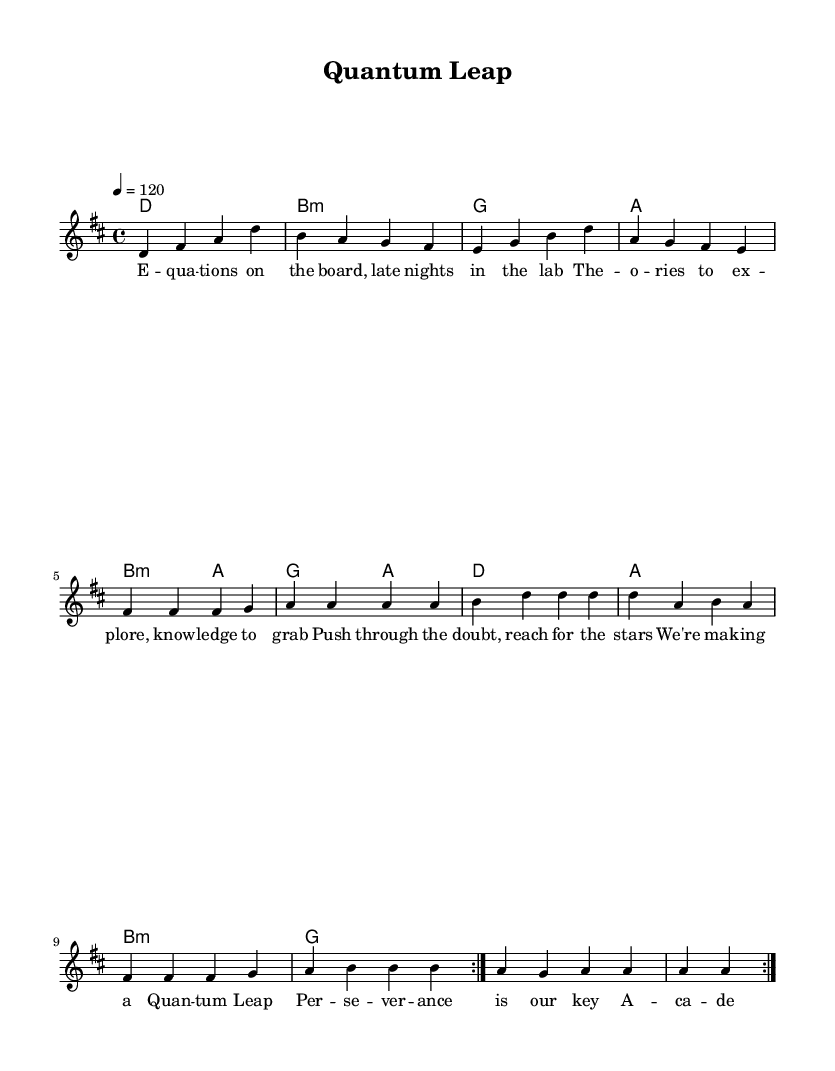What is the key signature of this music? The key signature is D major, which features two sharps (F# and C#). This can be identified at the beginning of the score where the key signature is placed.
Answer: D major What is the time signature of this music? The time signature is 4/4, indicating four beats in each measure and that a quarter note gets one beat. This is directly shown in the score next to the key signature.
Answer: 4/4 What is the tempo marking of this music? The tempo marking is 120 beats per minute, indicated by the instruction "4 = 120" at the beginning of the score, which specifies the speed at which the piece should be played.
Answer: 120 How many measures are in the repeated section? The repeated section consists of 8 measures as indicated by the repeat sign at the end of the first section. Counting the notes in this section confirms 8 measures are present.
Answer: 8 What are the first two words of the lyrics? The first two words of the lyrics are "E" and "qua", which can be found at the beginning of the lyric text under the melody.
Answer: E qua Which chord appears most frequently in the harmonies? The chord appearing most frequently is D major, as it is the first chord in the progression and also appears in the second occurrence of the repetition twice.
Answer: D What theme do the lyrics primarily reflect? The theme primarily reflects academic achievement, emphasizing perseverance and aspiration, which is clear from the content of the lyrics discussing theories, doubts, and dreams.
Answer: Academic achievement 